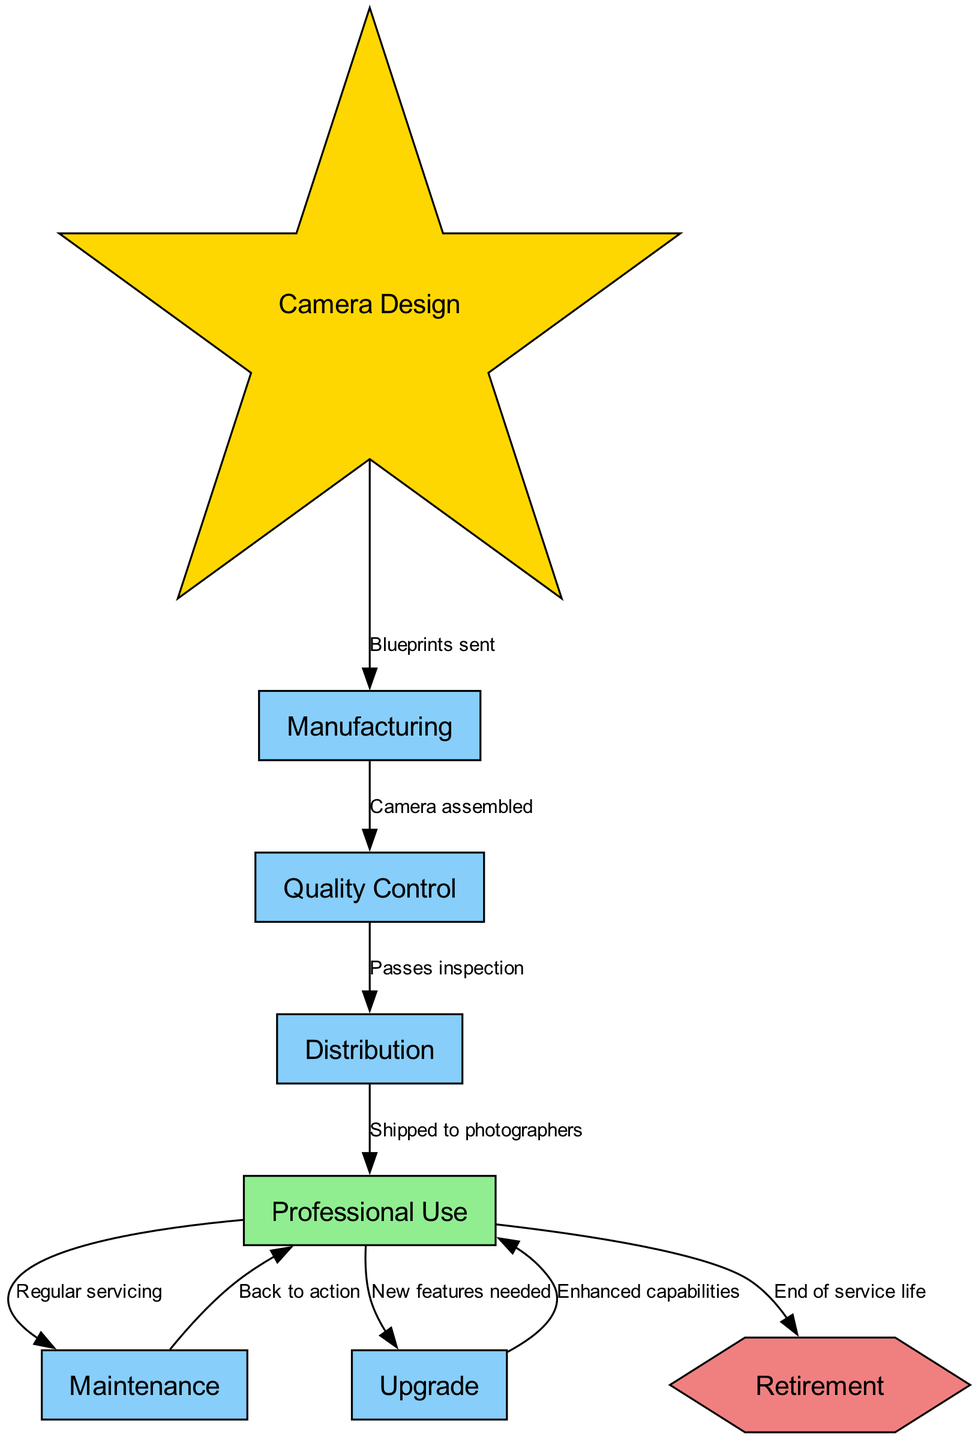What is the first step in the camera lifecycle? The diagram indicates that the first step is "Camera Design," which is the starting node where the design process occurs before manufacturing.
Answer: Camera Design How many nodes are in the diagram? The diagram lists a total of eight nodes, which represent distinct stages in the lifecycle of a professional camera.
Answer: Eight What do blueprints get sent for? The blueprints are sent for "Manufacturing," which is the next step in the lifecycle after the "Camera Design." This relationship is indicated through the edge labeled "Blueprints sent."
Answer: Manufacturing What is done during "Quality Control"? The diagram shows that during "Quality Control," the process involves checking that the "Camera assembled" passes inspection before it can move on to distribution.
Answer: Passes inspection What happens after "Professional Use"? After "Professional Use," the diagram indicates that the next step is "Maintenance," where regular servicing takes place to ensure the camera continues to function well for the photographers.
Answer: Maintenance What is the purpose of the "Upgrade" step? The "Upgrade" step occurs when there are "New features needed," highlighting that cameras may need updates and enhancements to improve their capabilities as technology advances or requirements change.
Answer: New features needed Which node has a hexagon shape? "Retirement" is customized in the diagram with a hexagon shape, visually distinguishing it as an endpoint in the camera lifecycle where the camera's service ends.
Answer: Retirement What is the relationship between "Maintenance" and "Professional Use"? The diagram shows a two-way relationship where after maintenance, the camera is sent "Back to action," indicating that it can return to being used professionally. This cyclical nature connects these two nodes closely in the workflow.
Answer: Back to action What colored node represents "Camera Design"? "Camera Design" is represented as a gold colored star-shaped node, indicating its importance as the starting point of the lifecycle.
Answer: Gold star 